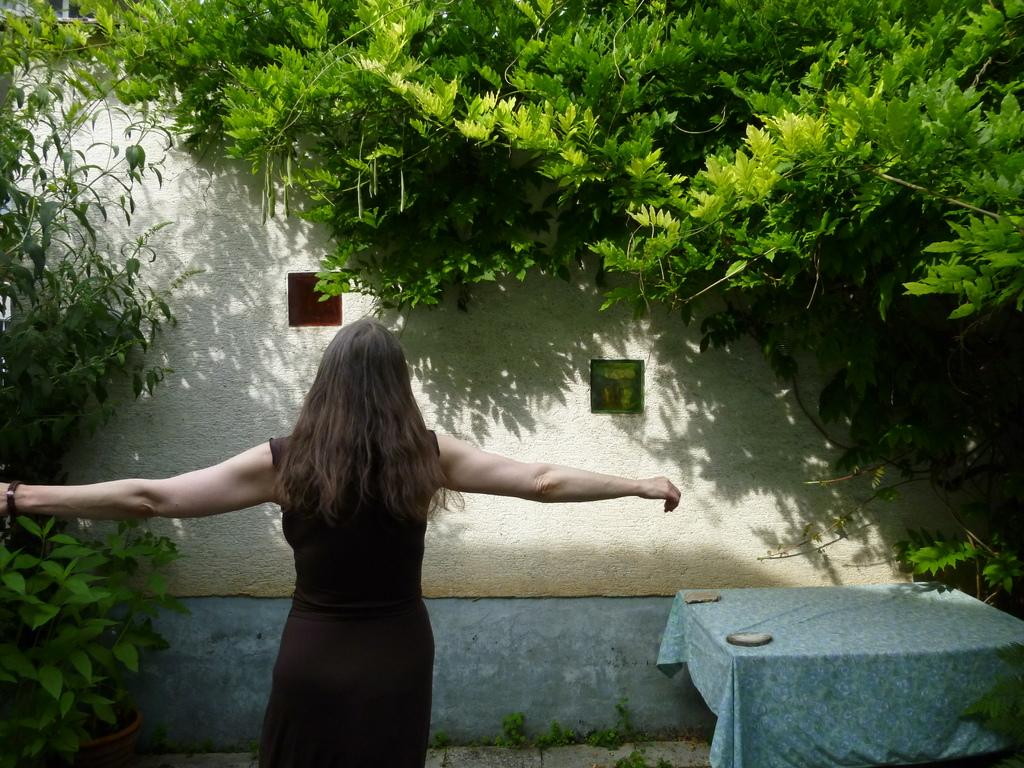What is the main subject in the image? There is a woman standing in the image. What can be seen in the background of the image? There is a wall in the image. What is on the table in the image? The table is covered with a cloth. What type of vegetation is visible in the image? There are trees with branches and leaves in the image. How does the woman print her thoughts in the image? There is no indication in the image that the woman is printing her thoughts. 